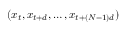<formula> <loc_0><loc_0><loc_500><loc_500>( x _ { t } , x _ { t + d } , \dots , x _ { t + ( N - 1 ) d } )</formula> 